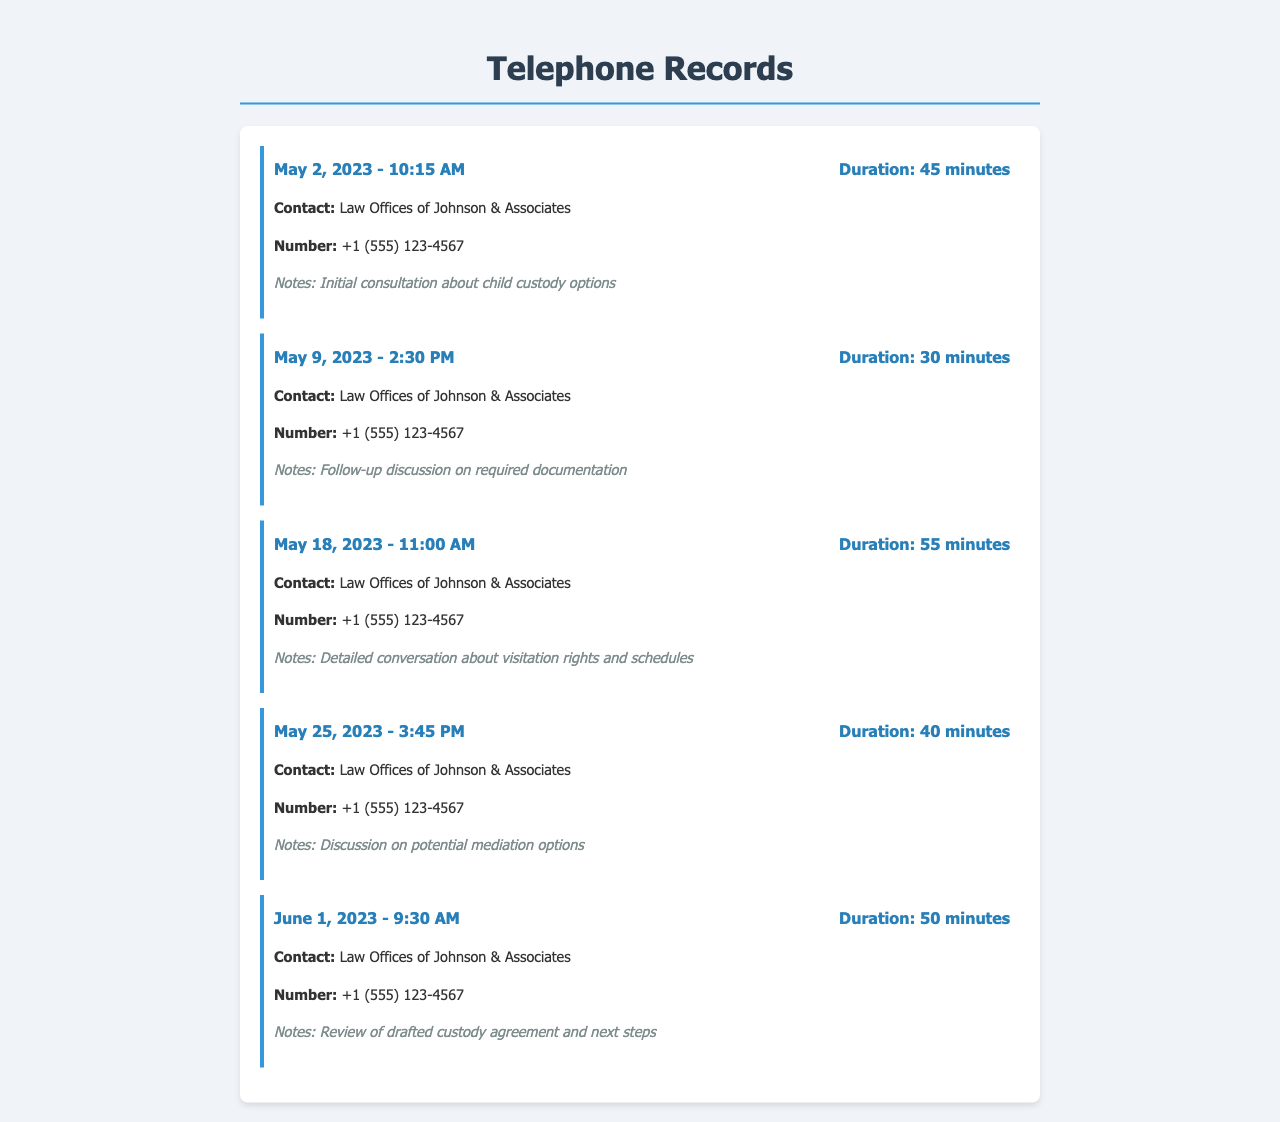What is the date of the first call? The first call occurred on May 2, 2023, as listed in the records.
Answer: May 2, 2023 What was the duration of the longest call? The longest call lasted for 55 minutes, as shown in the duration details.
Answer: 55 minutes What contact number is associated with the lawyer's office? The records provide a specific phone number for the office, which is listed beneath the contact name.
Answer: +1 (555) 123-4567 How many calls were made in May 2023? The records show a total of four calls made in May 2023.
Answer: 4 What was discussed during the call on May 18, 2023? The notes indicate that the conversation focused on visitation rights and schedules.
Answer: Visitation rights and schedules Which call had the topic of mediation options? The call on May 25, 2023, specifically mentioned discussing potential mediation options.
Answer: May 25, 2023 What was the purpose of the call on June 1, 2023? The notes describe the call as a review of the drafted custody agreement and next steps.
Answer: Review of drafted custody agreement and next steps What time was the call on May 9, 2023? The record clearly states that the call took place at 2:30 PM.
Answer: 2:30 PM How many calls had a duration of less than 45 minutes? Two calls were shorter than 45 minutes, specifically the second and fourth calls.
Answer: 2 